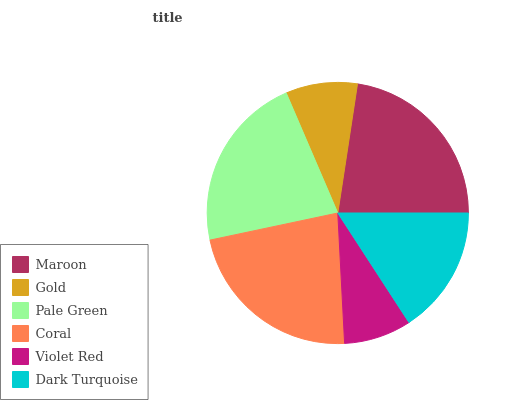Is Violet Red the minimum?
Answer yes or no. Yes. Is Maroon the maximum?
Answer yes or no. Yes. Is Gold the minimum?
Answer yes or no. No. Is Gold the maximum?
Answer yes or no. No. Is Maroon greater than Gold?
Answer yes or no. Yes. Is Gold less than Maroon?
Answer yes or no. Yes. Is Gold greater than Maroon?
Answer yes or no. No. Is Maroon less than Gold?
Answer yes or no. No. Is Pale Green the high median?
Answer yes or no. Yes. Is Dark Turquoise the low median?
Answer yes or no. Yes. Is Maroon the high median?
Answer yes or no. No. Is Pale Green the low median?
Answer yes or no. No. 